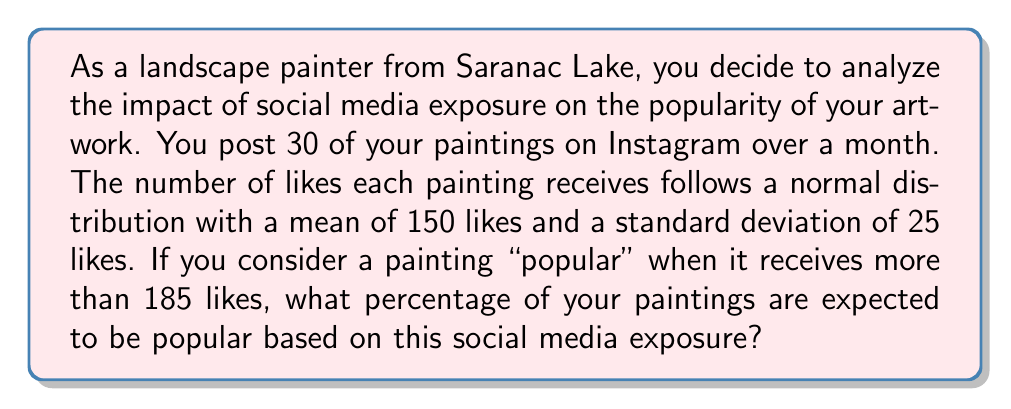Can you solve this math problem? To solve this problem, we need to use the properties of the normal distribution and calculate the z-score for the "popular" threshold. Then, we'll use the standard normal distribution table or a calculator to find the probability.

Given:
- The number of likes follows a normal distribution
- Mean ($\mu$) = 150 likes
- Standard deviation ($\sigma$) = 25 likes
- "Popular" threshold = 185 likes

Step 1: Calculate the z-score for 185 likes
The z-score formula is:
$$z = \frac{x - \mu}{\sigma}$$

Where:
$x$ = the value of interest (185 likes)
$\mu$ = the mean (150 likes)
$\sigma$ = the standard deviation (25 likes)

Plugging in the values:
$$z = \frac{185 - 150}{25} = \frac{35}{25} = 1.4$$

Step 2: Find the probability of a painting receiving more than 185 likes
We need to find P(X > 185), which is equivalent to finding the area under the standard normal curve to the right of z = 1.4.

Using a standard normal distribution table or calculator, we find:
P(Z > 1.4) ≈ 0.0808

Step 3: Convert the probability to a percentage
0.0808 × 100% = 8.08%

Therefore, approximately 8.08% of your paintings are expected to be popular based on this social media exposure.
Answer: 8.08% 